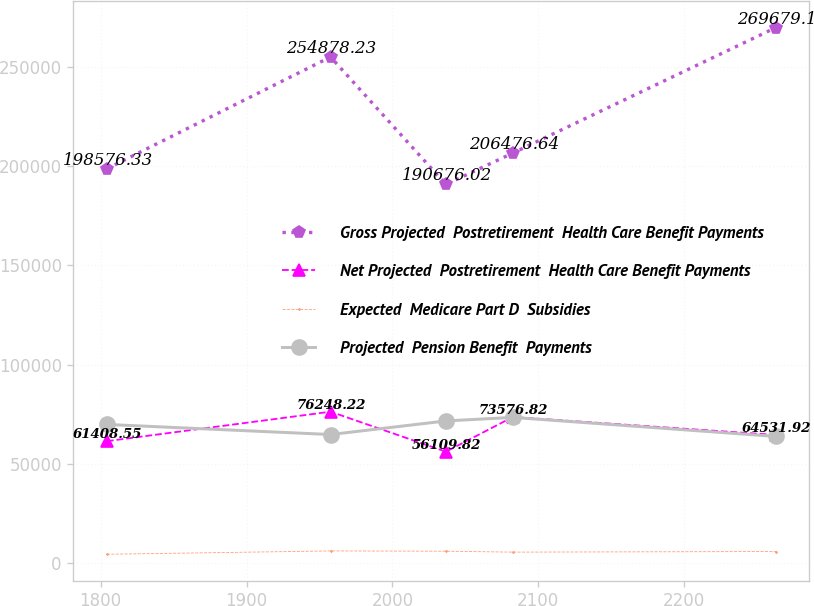Convert chart to OTSL. <chart><loc_0><loc_0><loc_500><loc_500><line_chart><ecel><fcel>Gross Projected  Postretirement  Health Care Benefit Payments<fcel>Net Projected  Postretirement  Health Care Benefit Payments<fcel>Expected  Medicare Part D  Subsidies<fcel>Projected  Pension Benefit  Payments<nl><fcel>1804.31<fcel>198576<fcel>61408.6<fcel>4453.74<fcel>69824.4<nl><fcel>1957.58<fcel>254878<fcel>76248.2<fcel>6139.44<fcel>64747<nl><fcel>2036.65<fcel>190676<fcel>56109.8<fcel>5990.82<fcel>71594.3<nl><fcel>2082.5<fcel>206477<fcel>73576.8<fcel>5532.62<fcel>73374<nl><fcel>2262.78<fcel>269679<fcel>64531.9<fcel>5842.2<fcel>63788.5<nl></chart> 